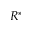<formula> <loc_0><loc_0><loc_500><loc_500>R ^ { * }</formula> 